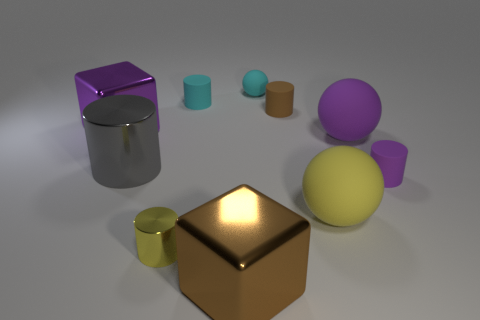Subtract all cyan cylinders. How many cylinders are left? 4 Subtract all purple cylinders. How many cylinders are left? 4 Subtract all yellow cylinders. Subtract all cyan spheres. How many cylinders are left? 4 Subtract all blocks. How many objects are left? 8 Add 1 big gray shiny things. How many big gray shiny things exist? 2 Subtract 0 red balls. How many objects are left? 10 Subtract all gray matte cylinders. Subtract all cyan cylinders. How many objects are left? 9 Add 6 large purple spheres. How many large purple spheres are left? 7 